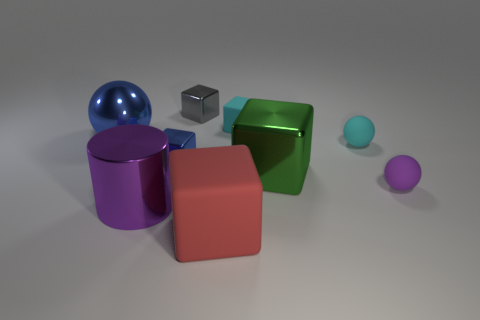There is a object that is on the left side of the tiny blue block and behind the big shiny block; what material is it?
Ensure brevity in your answer.  Metal. What is the color of the large block that is in front of the small rubber thing that is in front of the shiny block that is to the right of the red matte block?
Offer a very short reply. Red. What number of brown objects are cylinders or big metallic blocks?
Offer a very short reply. 0. How many other objects are the same size as the purple shiny cylinder?
Your answer should be very brief. 3. How many tiny rubber objects are there?
Offer a very short reply. 3. Are there any other things that are the same shape as the large red rubber thing?
Ensure brevity in your answer.  Yes. Are the purple thing that is in front of the small purple rubber thing and the purple thing right of the large metallic cube made of the same material?
Your answer should be compact. No. What is the small purple thing made of?
Offer a terse response. Rubber. What number of small purple things have the same material as the big red thing?
Make the answer very short. 1. What number of metallic things are either large red things or tiny cyan balls?
Give a very brief answer. 0. 